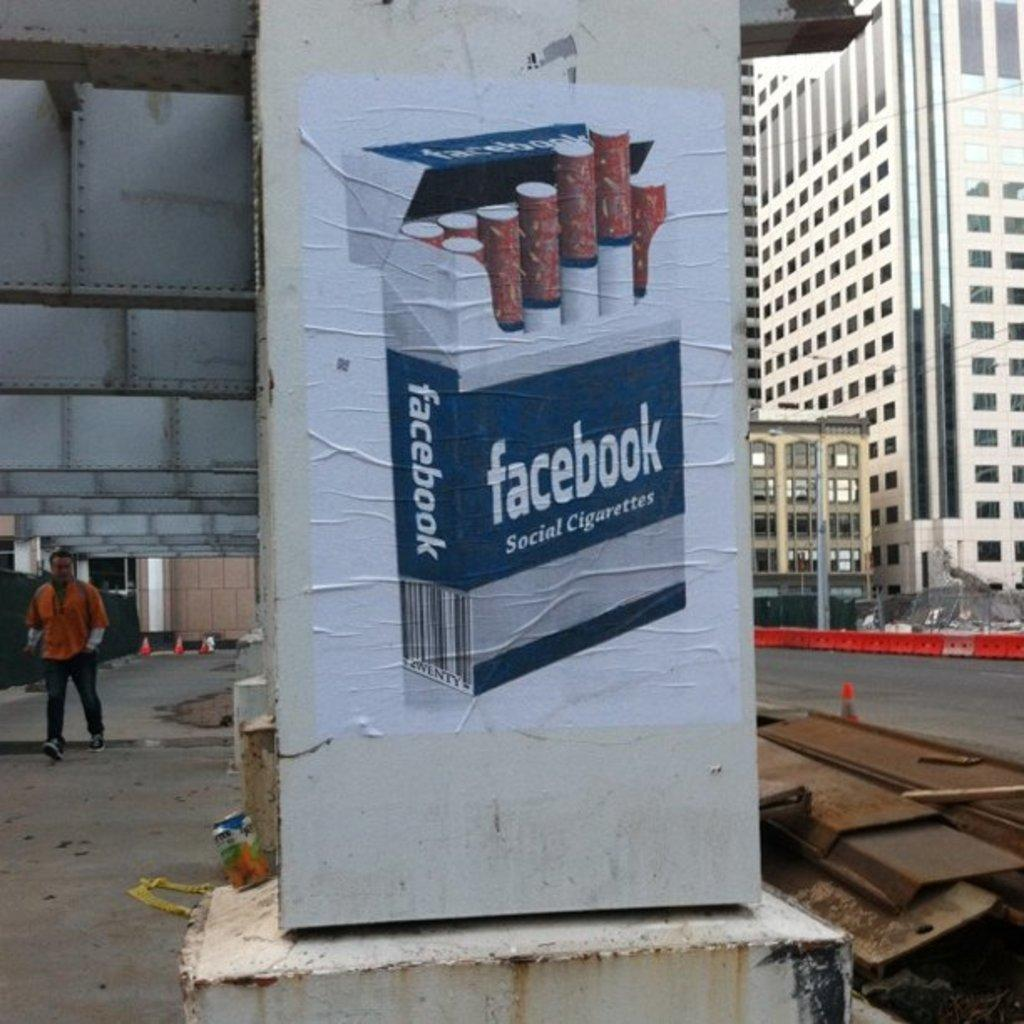What type of visual is the image? The image is a poster. How is the poster displayed? The poster is attached to a pillar. What can be seen in the background of the image? There are buildings with windows in the image. What is happening in the image? There is a person walking in the image, and it appears to depict a flyover. What type of structure is present in the image? There are iron pillars in the image. What type of cat can be seen playing with a feather in the image? There is no cat or feather present in the image; it features a poster with a person walking and a flyover. What type of drug is being sold in the image? There is no reference to any drug in the image, which is a poster depicting a flyover and a person walking. 